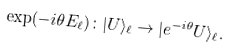<formula> <loc_0><loc_0><loc_500><loc_500>\exp ( - i \theta E _ { \ell } ) \colon | U \rangle _ { \ell } \to | e ^ { - i \theta } U \rangle _ { \ell } .</formula> 